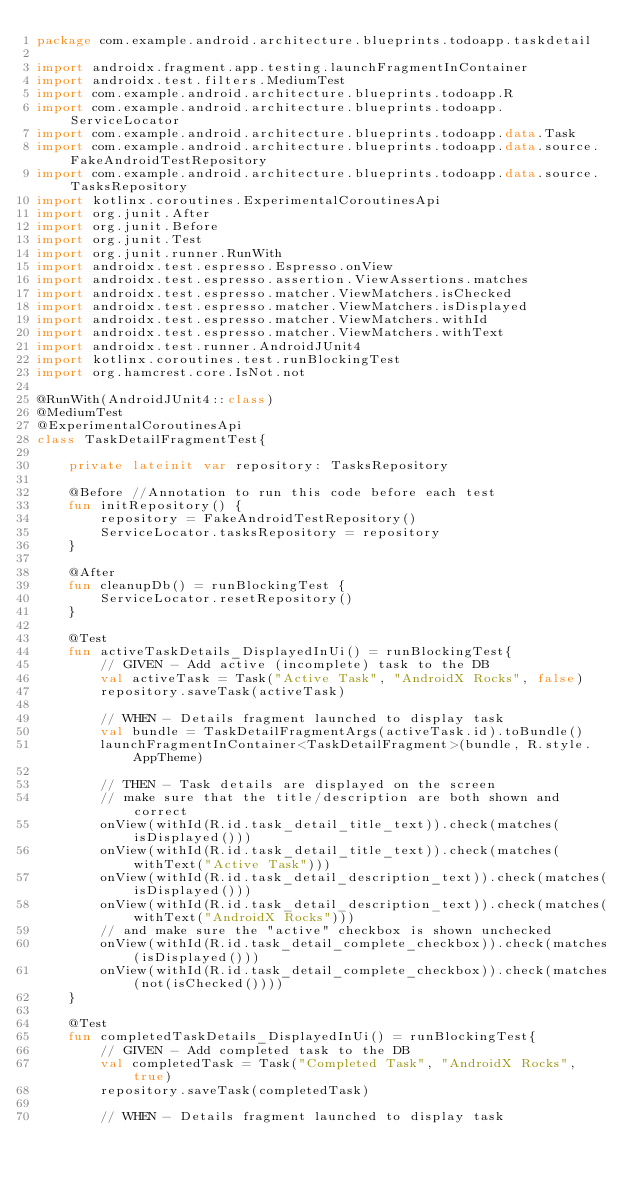Convert code to text. <code><loc_0><loc_0><loc_500><loc_500><_Kotlin_>package com.example.android.architecture.blueprints.todoapp.taskdetail

import androidx.fragment.app.testing.launchFragmentInContainer
import androidx.test.filters.MediumTest
import com.example.android.architecture.blueprints.todoapp.R
import com.example.android.architecture.blueprints.todoapp.ServiceLocator
import com.example.android.architecture.blueprints.todoapp.data.Task
import com.example.android.architecture.blueprints.todoapp.data.source.FakeAndroidTestRepository
import com.example.android.architecture.blueprints.todoapp.data.source.TasksRepository
import kotlinx.coroutines.ExperimentalCoroutinesApi
import org.junit.After
import org.junit.Before
import org.junit.Test
import org.junit.runner.RunWith
import androidx.test.espresso.Espresso.onView
import androidx.test.espresso.assertion.ViewAssertions.matches
import androidx.test.espresso.matcher.ViewMatchers.isChecked
import androidx.test.espresso.matcher.ViewMatchers.isDisplayed
import androidx.test.espresso.matcher.ViewMatchers.withId
import androidx.test.espresso.matcher.ViewMatchers.withText
import androidx.test.runner.AndroidJUnit4
import kotlinx.coroutines.test.runBlockingTest
import org.hamcrest.core.IsNot.not

@RunWith(AndroidJUnit4::class)
@MediumTest
@ExperimentalCoroutinesApi
class TaskDetailFragmentTest{

    private lateinit var repository: TasksRepository

    @Before //Annotation to run this code before each test
    fun initRepository() {
        repository = FakeAndroidTestRepository()
        ServiceLocator.tasksRepository = repository
    }

    @After
    fun cleanupDb() = runBlockingTest {
        ServiceLocator.resetRepository()
    }

    @Test
    fun activeTaskDetails_DisplayedInUi() = runBlockingTest{
        // GIVEN - Add active (incomplete) task to the DB
        val activeTask = Task("Active Task", "AndroidX Rocks", false)
        repository.saveTask(activeTask)

        // WHEN - Details fragment launched to display task
        val bundle = TaskDetailFragmentArgs(activeTask.id).toBundle()
        launchFragmentInContainer<TaskDetailFragment>(bundle, R.style.AppTheme)

        // THEN - Task details are displayed on the screen
        // make sure that the title/description are both shown and correct
        onView(withId(R.id.task_detail_title_text)).check(matches(isDisplayed()))
        onView(withId(R.id.task_detail_title_text)).check(matches(withText("Active Task")))
        onView(withId(R.id.task_detail_description_text)).check(matches(isDisplayed()))
        onView(withId(R.id.task_detail_description_text)).check(matches(withText("AndroidX Rocks")))
        // and make sure the "active" checkbox is shown unchecked
        onView(withId(R.id.task_detail_complete_checkbox)).check(matches(isDisplayed()))
        onView(withId(R.id.task_detail_complete_checkbox)).check(matches(not(isChecked())))
    }

    @Test
    fun completedTaskDetails_DisplayedInUi() = runBlockingTest{
        // GIVEN - Add completed task to the DB
        val completedTask = Task("Completed Task", "AndroidX Rocks", true)
        repository.saveTask(completedTask)

        // WHEN - Details fragment launched to display task</code> 